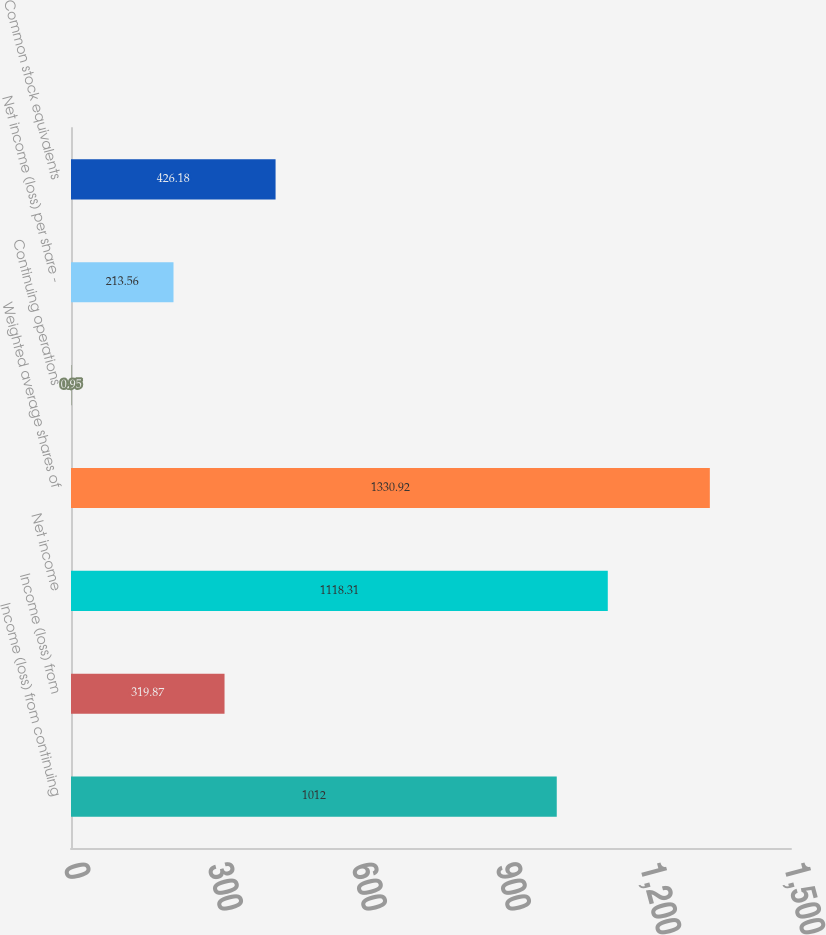<chart> <loc_0><loc_0><loc_500><loc_500><bar_chart><fcel>Income (loss) from continuing<fcel>Income (loss) from<fcel>Net income<fcel>Weighted average shares of<fcel>Continuing operations<fcel>Net income (loss) per share -<fcel>Common stock equivalents<nl><fcel>1012<fcel>319.87<fcel>1118.31<fcel>1330.92<fcel>0.95<fcel>213.56<fcel>426.18<nl></chart> 